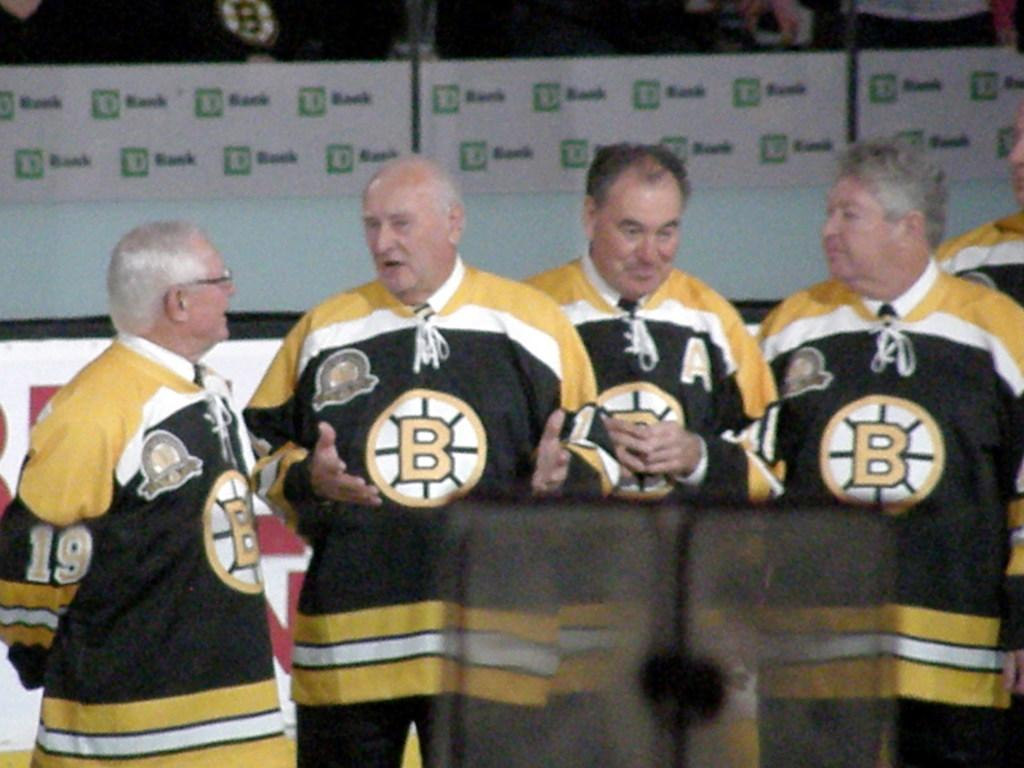<image>
Share a concise interpretation of the image provided. Four men with "B" jerseys stand together talking. 